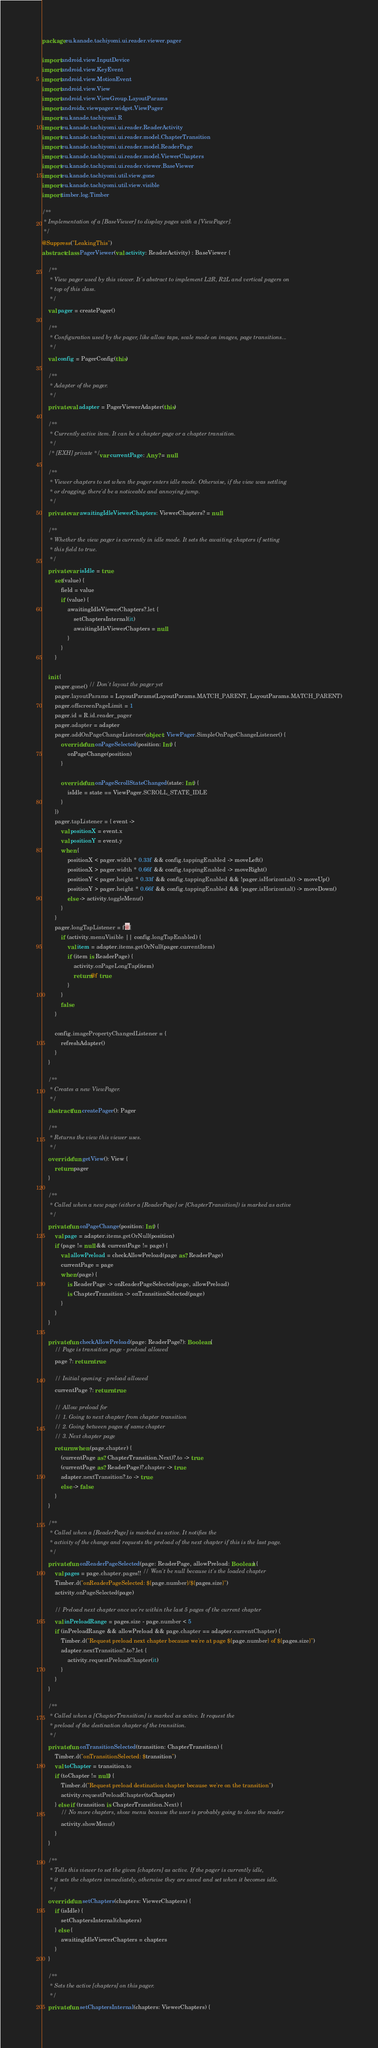<code> <loc_0><loc_0><loc_500><loc_500><_Kotlin_>package eu.kanade.tachiyomi.ui.reader.viewer.pager

import android.view.InputDevice
import android.view.KeyEvent
import android.view.MotionEvent
import android.view.View
import android.view.ViewGroup.LayoutParams
import androidx.viewpager.widget.ViewPager
import eu.kanade.tachiyomi.R
import eu.kanade.tachiyomi.ui.reader.ReaderActivity
import eu.kanade.tachiyomi.ui.reader.model.ChapterTransition
import eu.kanade.tachiyomi.ui.reader.model.ReaderPage
import eu.kanade.tachiyomi.ui.reader.model.ViewerChapters
import eu.kanade.tachiyomi.ui.reader.viewer.BaseViewer
import eu.kanade.tachiyomi.util.view.gone
import eu.kanade.tachiyomi.util.view.visible
import timber.log.Timber

/**
 * Implementation of a [BaseViewer] to display pages with a [ViewPager].
 */
@Suppress("LeakingThis")
abstract class PagerViewer(val activity: ReaderActivity) : BaseViewer {

    /**
     * View pager used by this viewer. It's abstract to implement L2R, R2L and vertical pagers on
     * top of this class.
     */
    val pager = createPager()

    /**
     * Configuration used by the pager, like allow taps, scale mode on images, page transitions...
     */
    val config = PagerConfig(this)

    /**
     * Adapter of the pager.
     */
    private val adapter = PagerViewerAdapter(this)

    /**
     * Currently active item. It can be a chapter page or a chapter transition.
     */
    /* [EXH] private */ var currentPage: Any? = null

    /**
     * Viewer chapters to set when the pager enters idle mode. Otherwise, if the view was settling
     * or dragging, there'd be a noticeable and annoying jump.
     */
    private var awaitingIdleViewerChapters: ViewerChapters? = null

    /**
     * Whether the view pager is currently in idle mode. It sets the awaiting chapters if setting
     * this field to true.
     */
    private var isIdle = true
        set(value) {
            field = value
            if (value) {
                awaitingIdleViewerChapters?.let {
                    setChaptersInternal(it)
                    awaitingIdleViewerChapters = null
                }
            }
        }

    init {
        pager.gone() // Don't layout the pager yet
        pager.layoutParams = LayoutParams(LayoutParams.MATCH_PARENT, LayoutParams.MATCH_PARENT)
        pager.offscreenPageLimit = 1
        pager.id = R.id.reader_pager
        pager.adapter = adapter
        pager.addOnPageChangeListener(object : ViewPager.SimpleOnPageChangeListener() {
            override fun onPageSelected(position: Int) {
                onPageChange(position)
            }

            override fun onPageScrollStateChanged(state: Int) {
                isIdle = state == ViewPager.SCROLL_STATE_IDLE
            }
        })
        pager.tapListener = { event ->
            val positionX = event.x
            val positionY = event.y
            when {
                positionX < pager.width * 0.33f && config.tappingEnabled -> moveLeft()
                positionX > pager.width * 0.66f && config.tappingEnabled -> moveRight()
                positionY < pager.height * 0.33f && config.tappingEnabled && !pager.isHorizontal() -> moveUp()
                positionY > pager.height * 0.66f && config.tappingEnabled && !pager.isHorizontal() -> moveDown()
                else -> activity.toggleMenu()
            }
        }
        pager.longTapListener = f@{
            if (activity.menuVisible || config.longTapEnabled) {
                val item = adapter.items.getOrNull(pager.currentItem)
                if (item is ReaderPage) {
                    activity.onPageLongTap(item)
                    return@f true
                }
            }
            false
        }

        config.imagePropertyChangedListener = {
            refreshAdapter()
        }
    }

    /**
     * Creates a new ViewPager.
     */
    abstract fun createPager(): Pager

    /**
     * Returns the view this viewer uses.
     */
    override fun getView(): View {
        return pager
    }

    /**
     * Called when a new page (either a [ReaderPage] or [ChapterTransition]) is marked as active
     */
    private fun onPageChange(position: Int) {
        val page = adapter.items.getOrNull(position)
        if (page != null && currentPage != page) {
            val allowPreload = checkAllowPreload(page as? ReaderPage)
            currentPage = page
            when (page) {
                is ReaderPage -> onReaderPageSelected(page, allowPreload)
                is ChapterTransition -> onTransitionSelected(page)
            }
        }
    }

    private fun checkAllowPreload(page: ReaderPage?): Boolean {
        // Page is transition page - preload allowed
        page ?: return true

        // Initial opening - preload allowed
        currentPage ?: return true

        // Allow preload for
        // 1. Going to next chapter from chapter transition
        // 2. Going between pages of same chapter
        // 3. Next chapter page
        return when (page.chapter) {
            (currentPage as? ChapterTransition.Next)?.to -> true
            (currentPage as? ReaderPage)?.chapter -> true
            adapter.nextTransition?.to -> true
            else -> false
        }
    }

    /**
     * Called when a [ReaderPage] is marked as active. It notifies the
     * activity of the change and requests the preload of the next chapter if this is the last page.
     */
    private fun onReaderPageSelected(page: ReaderPage, allowPreload: Boolean) {
        val pages = page.chapter.pages!! // Won't be null because it's the loaded chapter
        Timber.d("onReaderPageSelected: ${page.number}/${pages.size}")
        activity.onPageSelected(page)

        // Preload next chapter once we're within the last 5 pages of the current chapter
        val inPreloadRange = pages.size - page.number < 5
        if (inPreloadRange && allowPreload && page.chapter == adapter.currentChapter) {
            Timber.d("Request preload next chapter because we're at page ${page.number} of ${pages.size}")
            adapter.nextTransition?.to?.let {
                activity.requestPreloadChapter(it)
            }
        }
    }

    /**
     * Called when a [ChapterTransition] is marked as active. It request the
     * preload of the destination chapter of the transition.
     */
    private fun onTransitionSelected(transition: ChapterTransition) {
        Timber.d("onTransitionSelected: $transition")
        val toChapter = transition.to
        if (toChapter != null) {
            Timber.d("Request preload destination chapter because we're on the transition")
            activity.requestPreloadChapter(toChapter)
        } else if (transition is ChapterTransition.Next) {
            // No more chapters, show menu because the user is probably going to close the reader
            activity.showMenu()
        }
    }

    /**
     * Tells this viewer to set the given [chapters] as active. If the pager is currently idle,
     * it sets the chapters immediately, otherwise they are saved and set when it becomes idle.
     */
    override fun setChapters(chapters: ViewerChapters) {
        if (isIdle) {
            setChaptersInternal(chapters)
        } else {
            awaitingIdleViewerChapters = chapters
        }
    }

    /**
     * Sets the active [chapters] on this pager.
     */
    private fun setChaptersInternal(chapters: ViewerChapters) {</code> 